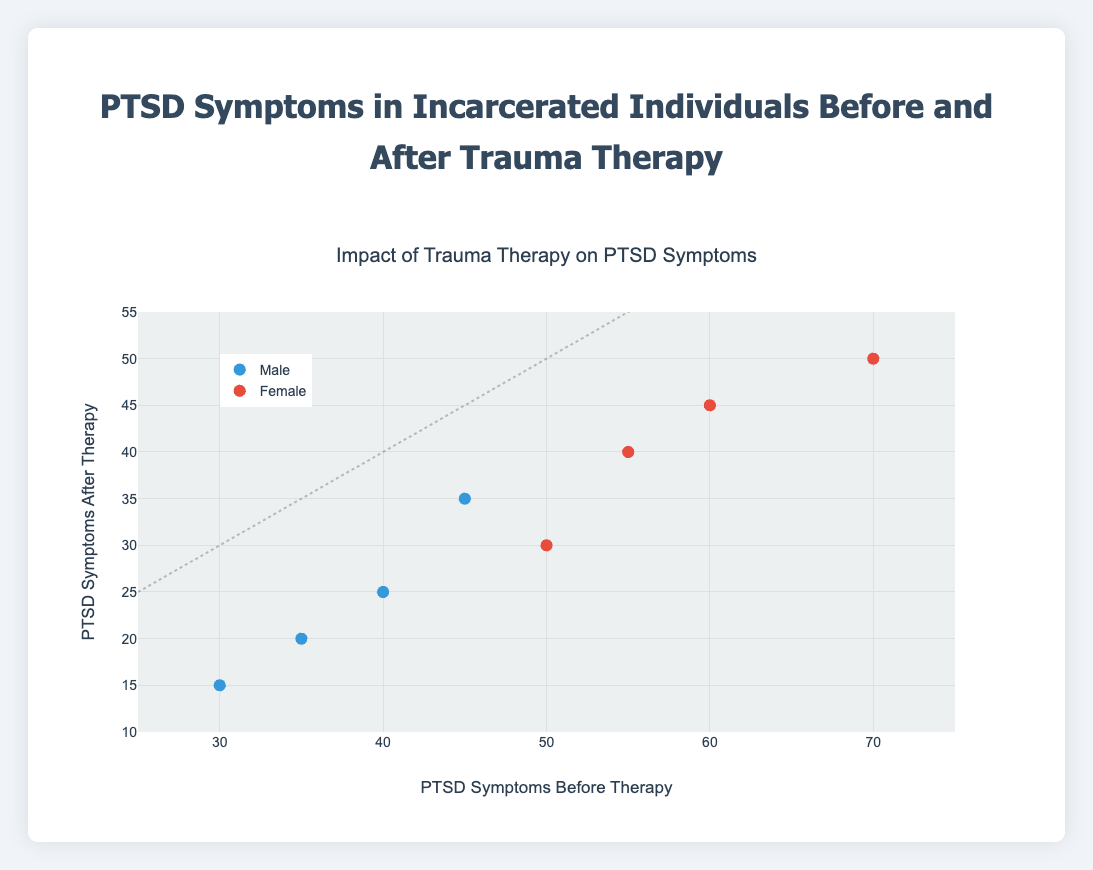What's the title of the figure? The title is usually located at the top of the figure and provides a summary of what the plot represents. In this case, the title is "Impact of Trauma Therapy on PTSD Symptoms".
Answer: Impact of Trauma Therapy on PTSD Symptoms What do the x-axis and y-axis represent? The labels on the axes provide this information. The x-axis represents "PTSD Symptoms Before Therapy" and the y-axis represents "PTSD Symptoms After Therapy".
Answer: x-axis: PTSD Symptoms Before Therapy, y-axis: PTSD Symptoms After Therapy How many data points are plotted for males? The data points can be counted manually or by referring to the data provided. There are 4 data points plotted for males.
Answer: 4 Which gender shows a greater overall reduction in PTSD symptoms? To determine this, compare the distance between the before and after data points for each gender. Male participants generally show a larger drop in PTSD symptoms from before to after the therapy.
Answer: Male Are there any data points where PTSD symptoms did not change after therapy? Look for data points that lie on the "No Change Line" which runs diagonally from the bottom left to the top right. There are no data points exactly on this line.
Answer: No What is the range of PTSD symptoms before therapy for males? Look at the x-coordinates of the male data points. The minimum and maximum x-values for males are 30 and 45, respectively.
Answer: 30 to 45 What is the average PTSD symptom reduction for females? Calculate the difference between the before and after values for the female participants and then find the average. Reductions are (50-30), (55-40), (60-45), and (70-50). Average reduction = (20 + 15 + 15 + 20) / 4 = 70 / 4 = 17.5
Answer: 17.5 Is there a trend in PTSD symptom reduction based on the initial severity before therapy? Examine whether the points closer to the top-left of the plot (indicating higher initial severity) show a larger reduction than those towards the bottom-right. Yes, individuals with higher initial PTSD symptoms generally see a larger reduction.
Answer: Yes What color represents male participants? The legend next to the plot shows the color coding for different genders. Male participants are represented in blue.
Answer: Blue How does the PTSD symptom reduction for female participants compare to that of male participants? Compare the y-values to the x-values for both genders. Female participants have smaller reductions on average compared to male participants.
Answer: Smaller reduction for females 